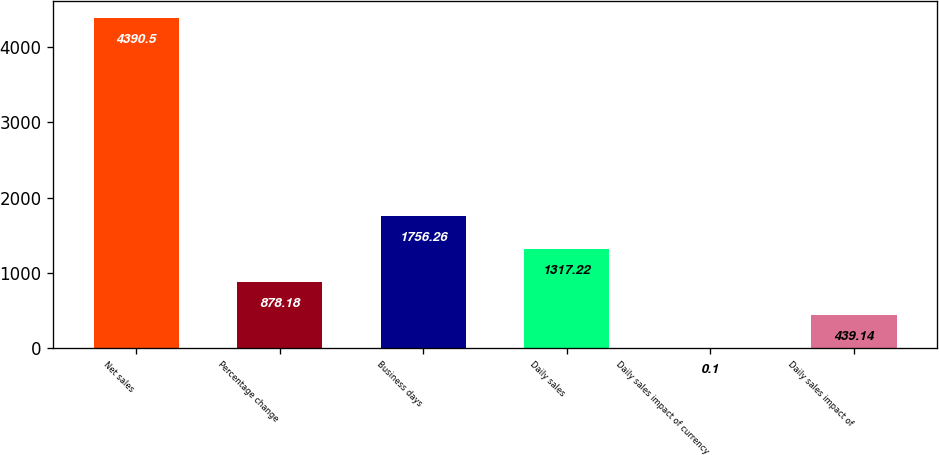Convert chart. <chart><loc_0><loc_0><loc_500><loc_500><bar_chart><fcel>Net sales<fcel>Percentage change<fcel>Business days<fcel>Daily sales<fcel>Daily sales impact of currency<fcel>Daily sales impact of<nl><fcel>4390.5<fcel>878.18<fcel>1756.26<fcel>1317.22<fcel>0.1<fcel>439.14<nl></chart> 